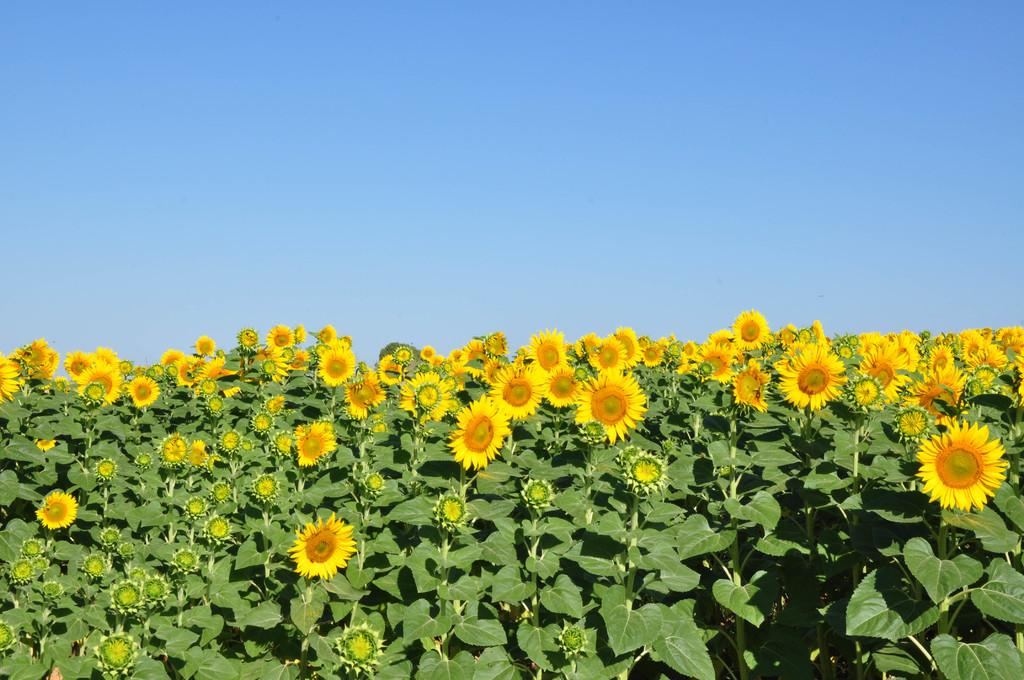What type of living organisms can be seen in the image? Plants can be seen in the image. What color are the flowers on some of the plants? Some of the plants have yellow flowers, and some have green flowers. What color is the sky in the background of the image? The sky is blue in the background of the image. What type of amusement can be seen in the image? There is no amusement present in the image; it features plants with yellow and green flowers against a blue sky. 